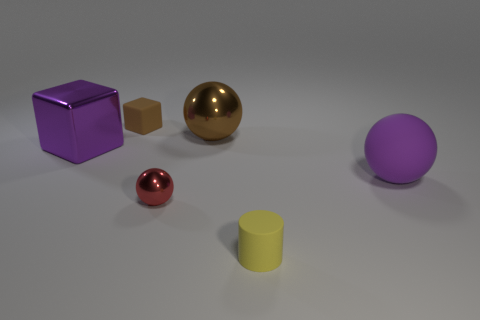There is a small red metallic ball; what number of small brown rubber things are in front of it?
Give a very brief answer. 0. What is the shape of the purple thing that is the same material as the small red object?
Your answer should be compact. Cube. Is the number of purple objects that are to the right of the small sphere less than the number of yellow things that are in front of the small brown rubber thing?
Keep it short and to the point. No. Are there more tiny cyan shiny cubes than cubes?
Your response must be concise. No. What is the tiny yellow thing made of?
Your answer should be compact. Rubber. What is the color of the tiny rubber object that is in front of the small red shiny sphere?
Offer a very short reply. Yellow. Is the number of tiny red metallic spheres behind the matte cube greater than the number of large brown objects on the right side of the rubber cylinder?
Your answer should be compact. No. There is a thing that is left of the matte thing that is behind the large purple object in front of the big cube; what is its size?
Offer a terse response. Large. Is there a metal ball of the same color as the tiny shiny thing?
Your answer should be compact. No. How many purple shiny blocks are there?
Give a very brief answer. 1. 